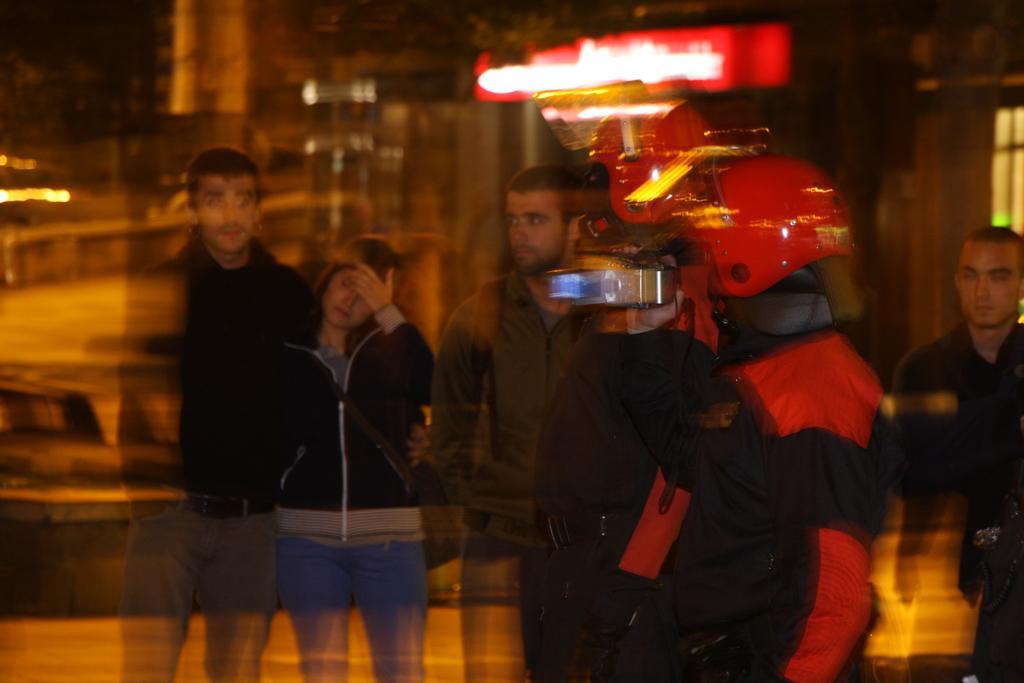Describe this image in one or two sentences. In this picture I can see group of people are standing. Here I can see red color object. 